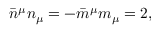Convert formula to latex. <formula><loc_0><loc_0><loc_500><loc_500>\bar { n } ^ { \mu } n _ { \mu } = - \bar { m } ^ { \mu } m _ { \mu } = 2 ,</formula> 